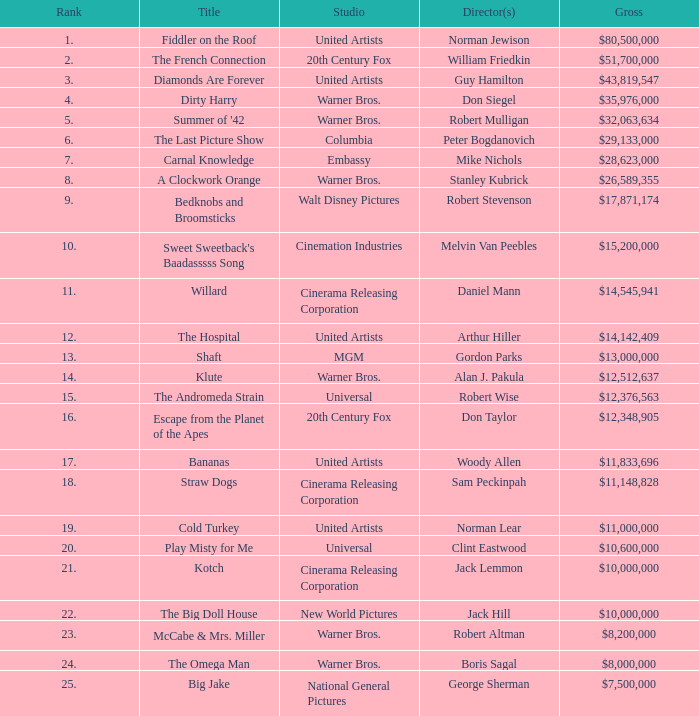What place does the title have with a gross earnings of $26,589,355? 8.0. Could you parse the entire table as a dict? {'header': ['Rank', 'Title', 'Studio', 'Director(s)', 'Gross'], 'rows': [['1.', 'Fiddler on the Roof', 'United Artists', 'Norman Jewison', '$80,500,000'], ['2.', 'The French Connection', '20th Century Fox', 'William Friedkin', '$51,700,000'], ['3.', 'Diamonds Are Forever', 'United Artists', 'Guy Hamilton', '$43,819,547'], ['4.', 'Dirty Harry', 'Warner Bros.', 'Don Siegel', '$35,976,000'], ['5.', "Summer of '42", 'Warner Bros.', 'Robert Mulligan', '$32,063,634'], ['6.', 'The Last Picture Show', 'Columbia', 'Peter Bogdanovich', '$29,133,000'], ['7.', 'Carnal Knowledge', 'Embassy', 'Mike Nichols', '$28,623,000'], ['8.', 'A Clockwork Orange', 'Warner Bros.', 'Stanley Kubrick', '$26,589,355'], ['9.', 'Bedknobs and Broomsticks', 'Walt Disney Pictures', 'Robert Stevenson', '$17,871,174'], ['10.', "Sweet Sweetback's Baadasssss Song", 'Cinemation Industries', 'Melvin Van Peebles', '$15,200,000'], ['11.', 'Willard', 'Cinerama Releasing Corporation', 'Daniel Mann', '$14,545,941'], ['12.', 'The Hospital', 'United Artists', 'Arthur Hiller', '$14,142,409'], ['13.', 'Shaft', 'MGM', 'Gordon Parks', '$13,000,000'], ['14.', 'Klute', 'Warner Bros.', 'Alan J. Pakula', '$12,512,637'], ['15.', 'The Andromeda Strain', 'Universal', 'Robert Wise', '$12,376,563'], ['16.', 'Escape from the Planet of the Apes', '20th Century Fox', 'Don Taylor', '$12,348,905'], ['17.', 'Bananas', 'United Artists', 'Woody Allen', '$11,833,696'], ['18.', 'Straw Dogs', 'Cinerama Releasing Corporation', 'Sam Peckinpah', '$11,148,828'], ['19.', 'Cold Turkey', 'United Artists', 'Norman Lear', '$11,000,000'], ['20.', 'Play Misty for Me', 'Universal', 'Clint Eastwood', '$10,600,000'], ['21.', 'Kotch', 'Cinerama Releasing Corporation', 'Jack Lemmon', '$10,000,000'], ['22.', 'The Big Doll House', 'New World Pictures', 'Jack Hill', '$10,000,000'], ['23.', 'McCabe & Mrs. Miller', 'Warner Bros.', 'Robert Altman', '$8,200,000'], ['24.', 'The Omega Man', 'Warner Bros.', 'Boris Sagal', '$8,000,000'], ['25.', 'Big Jake', 'National General Pictures', 'George Sherman', '$7,500,000']]} 